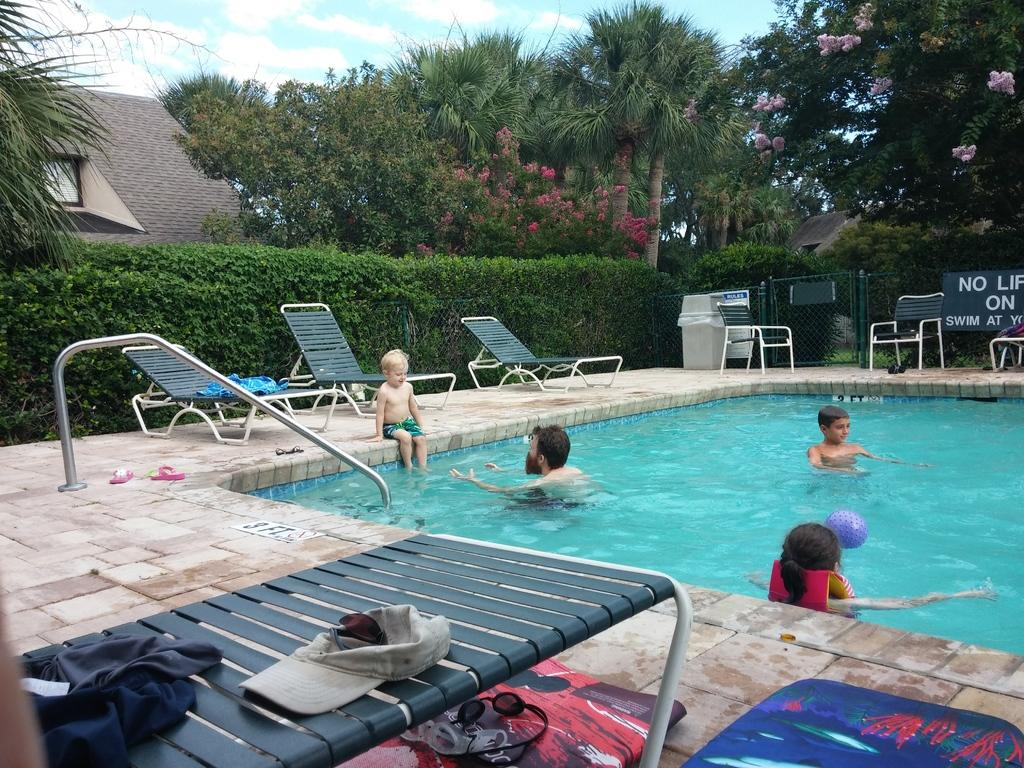What is the main feature of the image? There is a swimming pool in the image. What are the people in the image doing? People are swimming and playing in the pool. Can you describe the location of the child in the image? There is a child sitting on a brick near the pool. What type of cable can be seen connecting the pool to the house in the image? There is no cable connecting the pool to the house in the image. What kind of curve is visible in the pool's design in the image? The image does not show any curves in the pool's design; it appears to be a rectangular shape. 